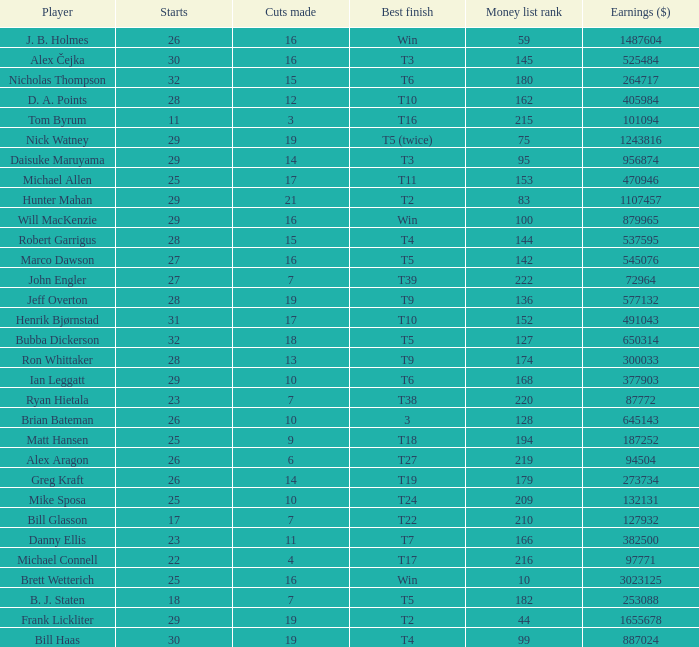What is the minimum number of starts for the players having a best finish of T18? 25.0. 